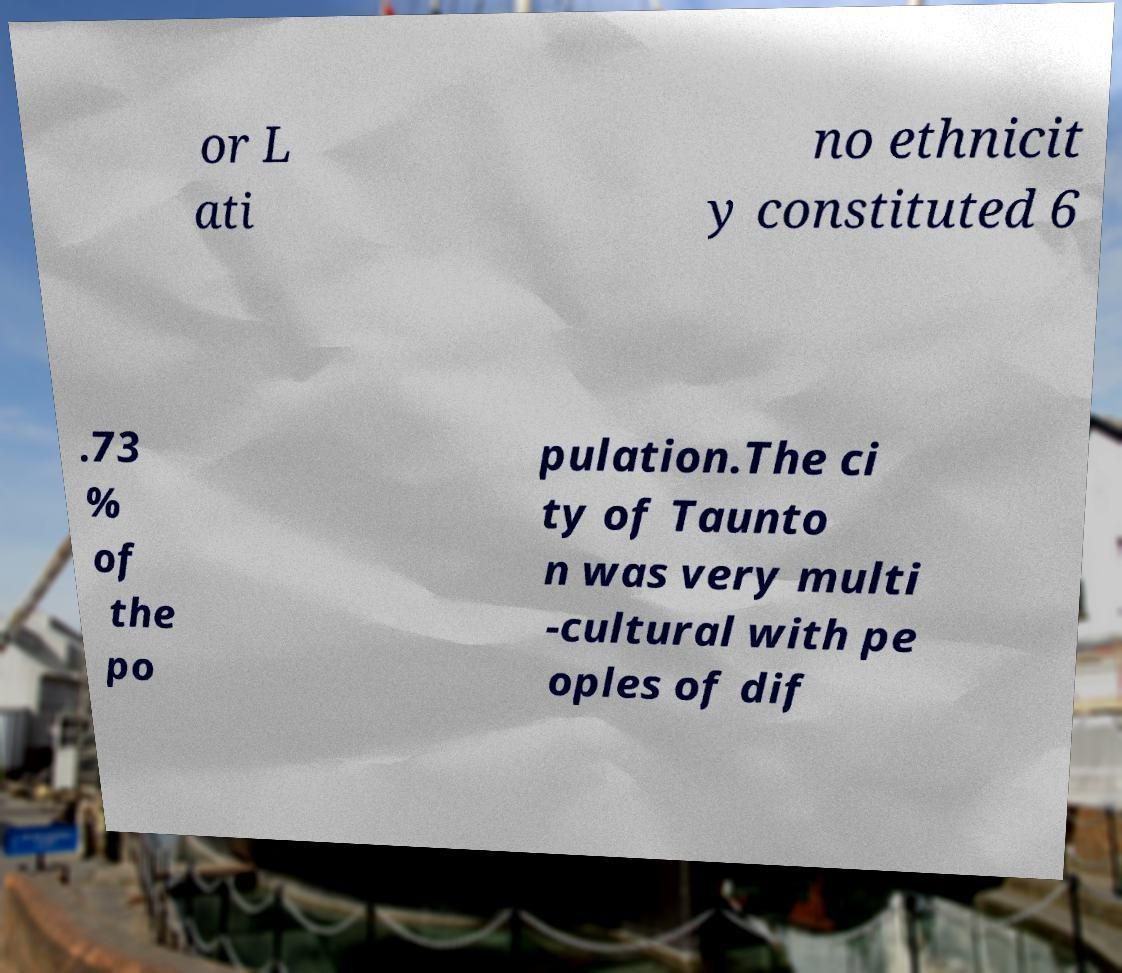Could you extract and type out the text from this image? or L ati no ethnicit y constituted 6 .73 % of the po pulation.The ci ty of Taunto n was very multi -cultural with pe oples of dif 